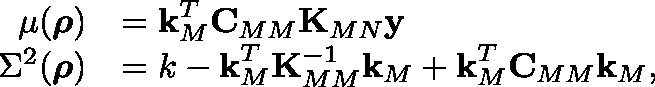<formula> <loc_0><loc_0><loc_500><loc_500>\begin{array} { r l } { \mu ( \rho ) } & { = k _ { M } ^ { T } C _ { M M } K _ { M N } y } \\ { \Sigma ^ { 2 } ( \rho ) } & { = k - k _ { M } ^ { T } K _ { M M } ^ { - 1 } k _ { M } + k _ { M } ^ { T } C _ { M M } k _ { M } , } \end{array}</formula> 